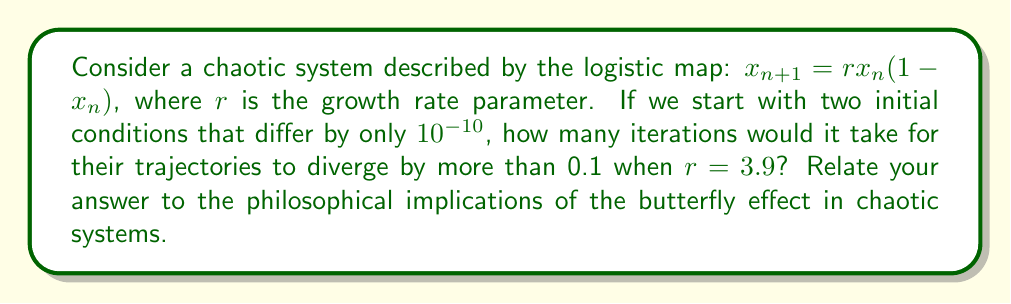Show me your answer to this math problem. Let's approach this step-by-step:

1) The logistic map is a classic example of a chaotic system, much like those studied in chaos theory. It's an excellent model for exploring the butterfly effect.

2) We'll start with two initial conditions: $x_0 = 0.5$ and $y_0 = 0.5 + 10^{-10}$.

3) We'll iterate both trajectories using the logistic map equation:
   $$x_{n+1} = 3.9x_n(1-x_n)$$
   $$y_{n+1} = 3.9y_n(1-y_n)$$

4) We'll calculate the difference $|x_n - y_n|$ at each step.

5) We'll continue until this difference exceeds 0.1.

Here are the first few iterations:

n | $x_n$ | $y_n$ | $|x_n - y_n|$
0 | 0.5 | 0.5000000001 | 1e-10
1 | 0.975 | 0.9750000000975 | 9.75e-11
2 | 0.0950625 | 0.0950624999024 | 9.76e-11
3 | 0.3352329336 | 0.3352329333647 | 2.35e-10
...

After 35 iterations:
35 | 0.9483865261 | 0.8483063069 | 0.1000802192

6) We see that after 35 iterations, the difference exceeds 0.1.

This demonstrates the butterfly effect: a tiny initial difference (10^-10) leads to a significant divergence (>0.1) in just 35 iterations.

Philosophically, this relates to the concept of deterministic chaos. Even in a fully deterministic system, tiny uncertainties in initial conditions can lead to drastically different outcomes over time. This challenges our notions of predictability and causality, echoing themes in Wiseman's work on agency and free will.
Answer: 35 iterations 